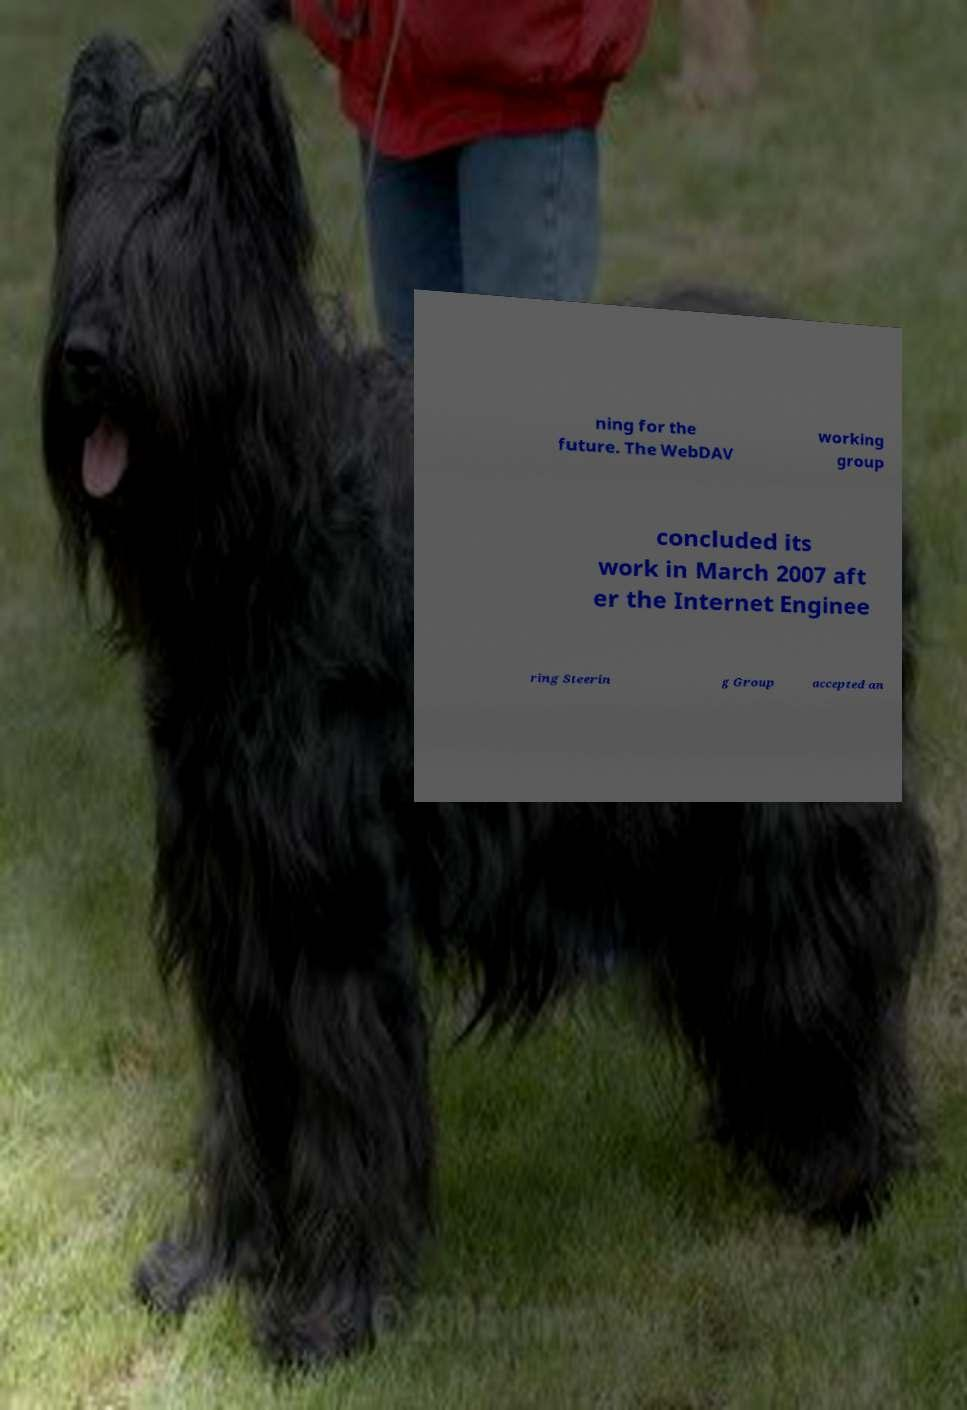Could you extract and type out the text from this image? ning for the future. The WebDAV working group concluded its work in March 2007 aft er the Internet Enginee ring Steerin g Group accepted an 